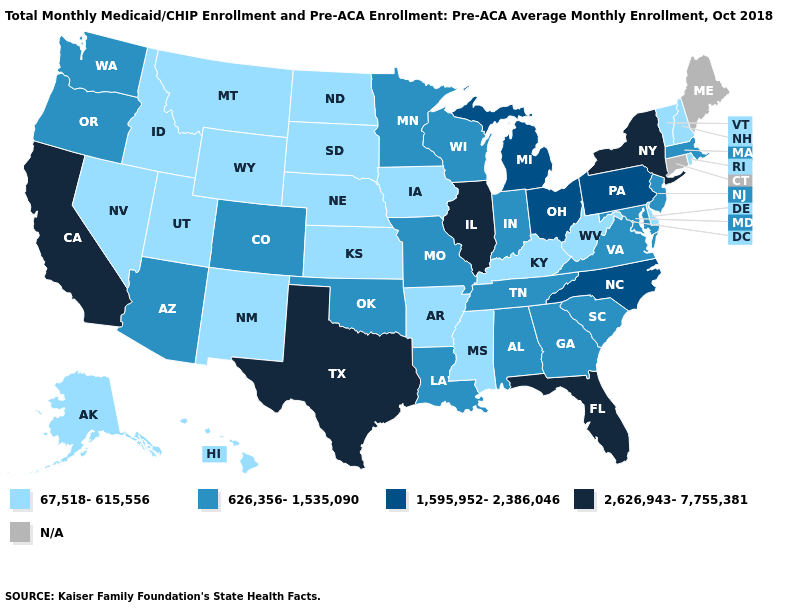Which states have the highest value in the USA?
Quick response, please. California, Florida, Illinois, New York, Texas. Does Rhode Island have the highest value in the USA?
Quick response, please. No. What is the value of Arizona?
Be succinct. 626,356-1,535,090. What is the value of Massachusetts?
Quick response, please. 626,356-1,535,090. What is the value of Arkansas?
Answer briefly. 67,518-615,556. What is the value of Utah?
Answer briefly. 67,518-615,556. Which states have the highest value in the USA?
Quick response, please. California, Florida, Illinois, New York, Texas. Among the states that border Montana , which have the highest value?
Keep it brief. Idaho, North Dakota, South Dakota, Wyoming. What is the lowest value in states that border Massachusetts?
Quick response, please. 67,518-615,556. What is the lowest value in states that border Arkansas?
Give a very brief answer. 67,518-615,556. How many symbols are there in the legend?
Quick response, please. 5. 